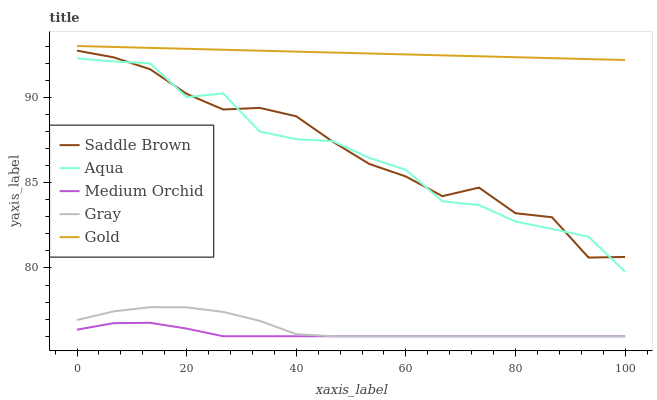Does Medium Orchid have the minimum area under the curve?
Answer yes or no. Yes. Does Gold have the maximum area under the curve?
Answer yes or no. Yes. Does Aqua have the minimum area under the curve?
Answer yes or no. No. Does Aqua have the maximum area under the curve?
Answer yes or no. No. Is Gold the smoothest?
Answer yes or no. Yes. Is Aqua the roughest?
Answer yes or no. Yes. Is Medium Orchid the smoothest?
Answer yes or no. No. Is Medium Orchid the roughest?
Answer yes or no. No. Does Gray have the lowest value?
Answer yes or no. Yes. Does Aqua have the lowest value?
Answer yes or no. No. Does Gold have the highest value?
Answer yes or no. Yes. Does Aqua have the highest value?
Answer yes or no. No. Is Medium Orchid less than Gold?
Answer yes or no. Yes. Is Gold greater than Saddle Brown?
Answer yes or no. Yes. Does Medium Orchid intersect Gray?
Answer yes or no. Yes. Is Medium Orchid less than Gray?
Answer yes or no. No. Is Medium Orchid greater than Gray?
Answer yes or no. No. Does Medium Orchid intersect Gold?
Answer yes or no. No. 